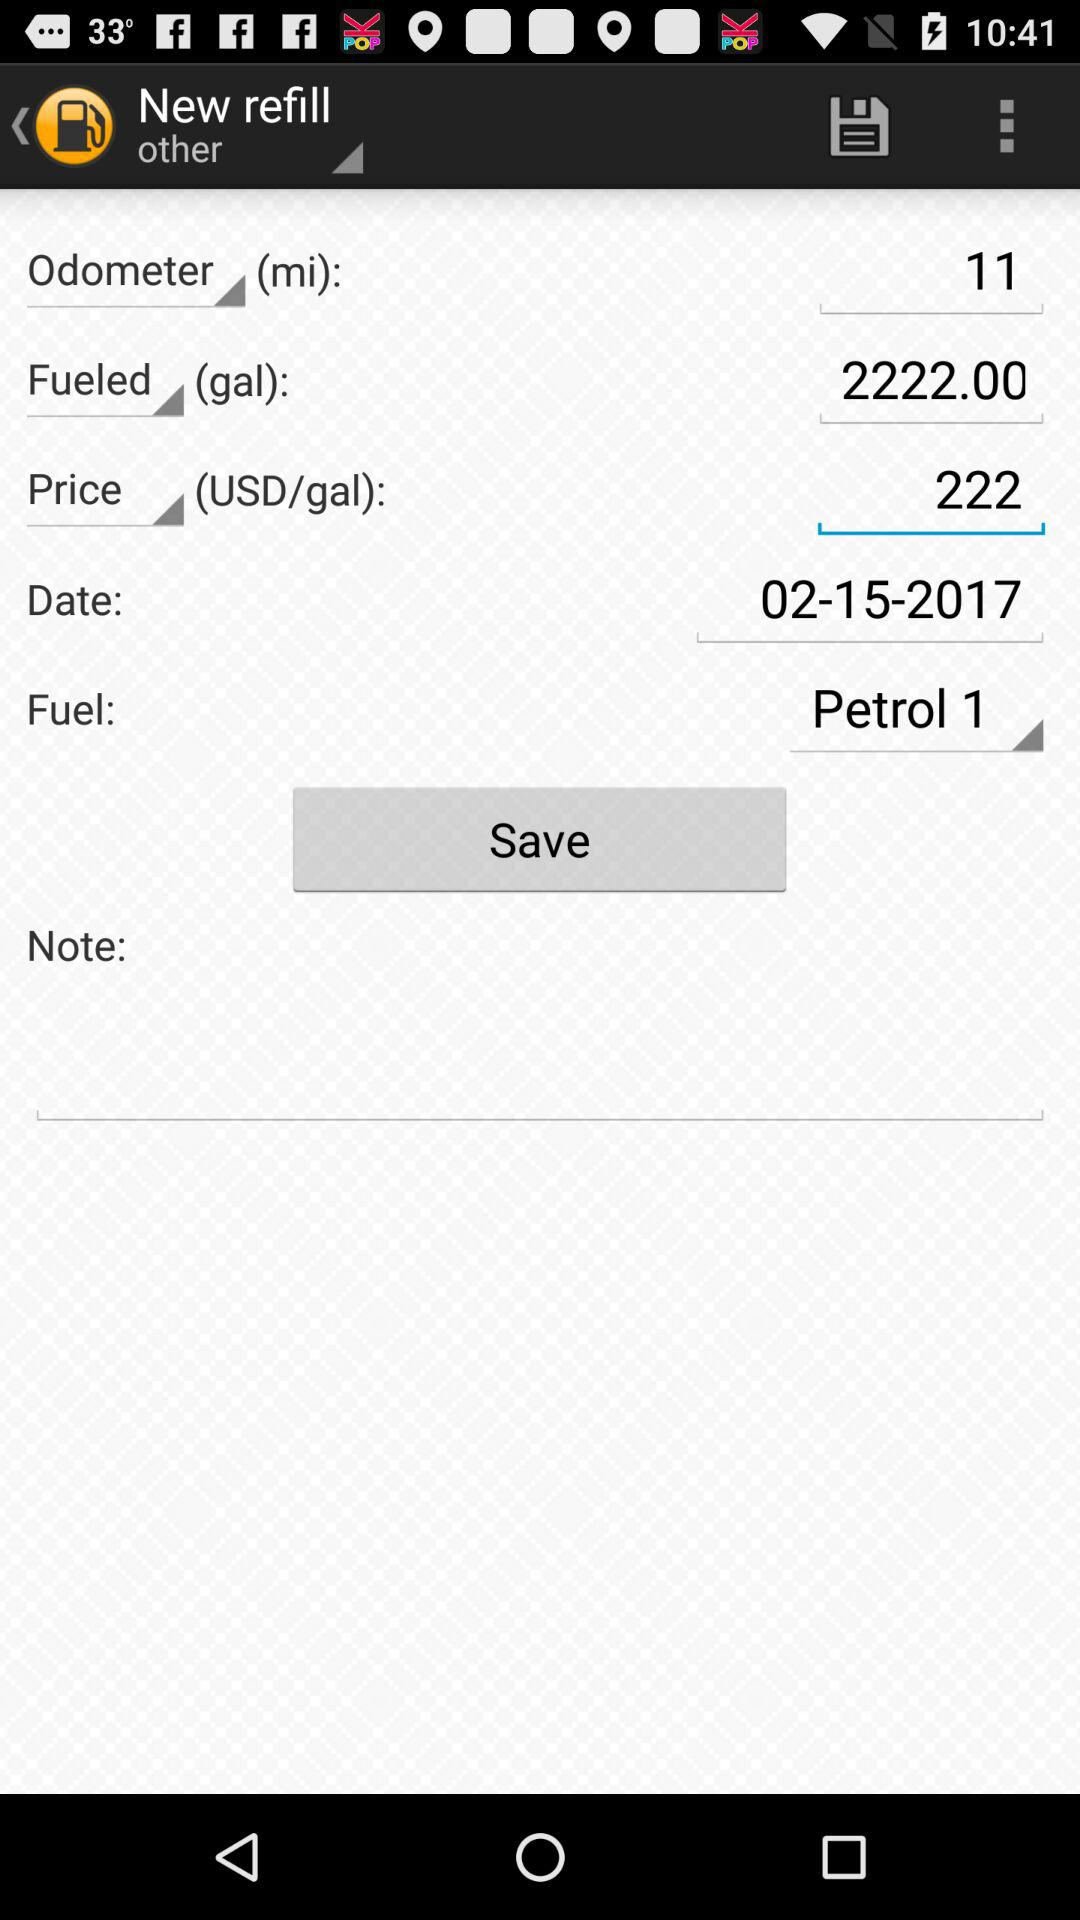What is the selected fuel type? The selected fuel type is "Petrol 1". 